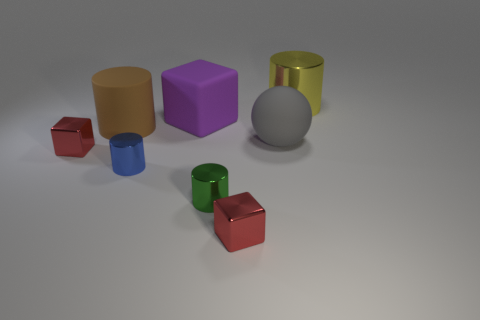Subtract all small cubes. How many cubes are left? 1 Subtract all blue spheres. How many red blocks are left? 2 Subtract all yellow cylinders. How many cylinders are left? 3 Add 1 small blue cylinders. How many objects exist? 9 Subtract all red cylinders. Subtract all cyan balls. How many cylinders are left? 4 Subtract all blocks. How many objects are left? 5 Subtract all small red blocks. Subtract all big cylinders. How many objects are left? 4 Add 4 gray rubber spheres. How many gray rubber spheres are left? 5 Add 5 small cylinders. How many small cylinders exist? 7 Subtract 0 gray blocks. How many objects are left? 8 